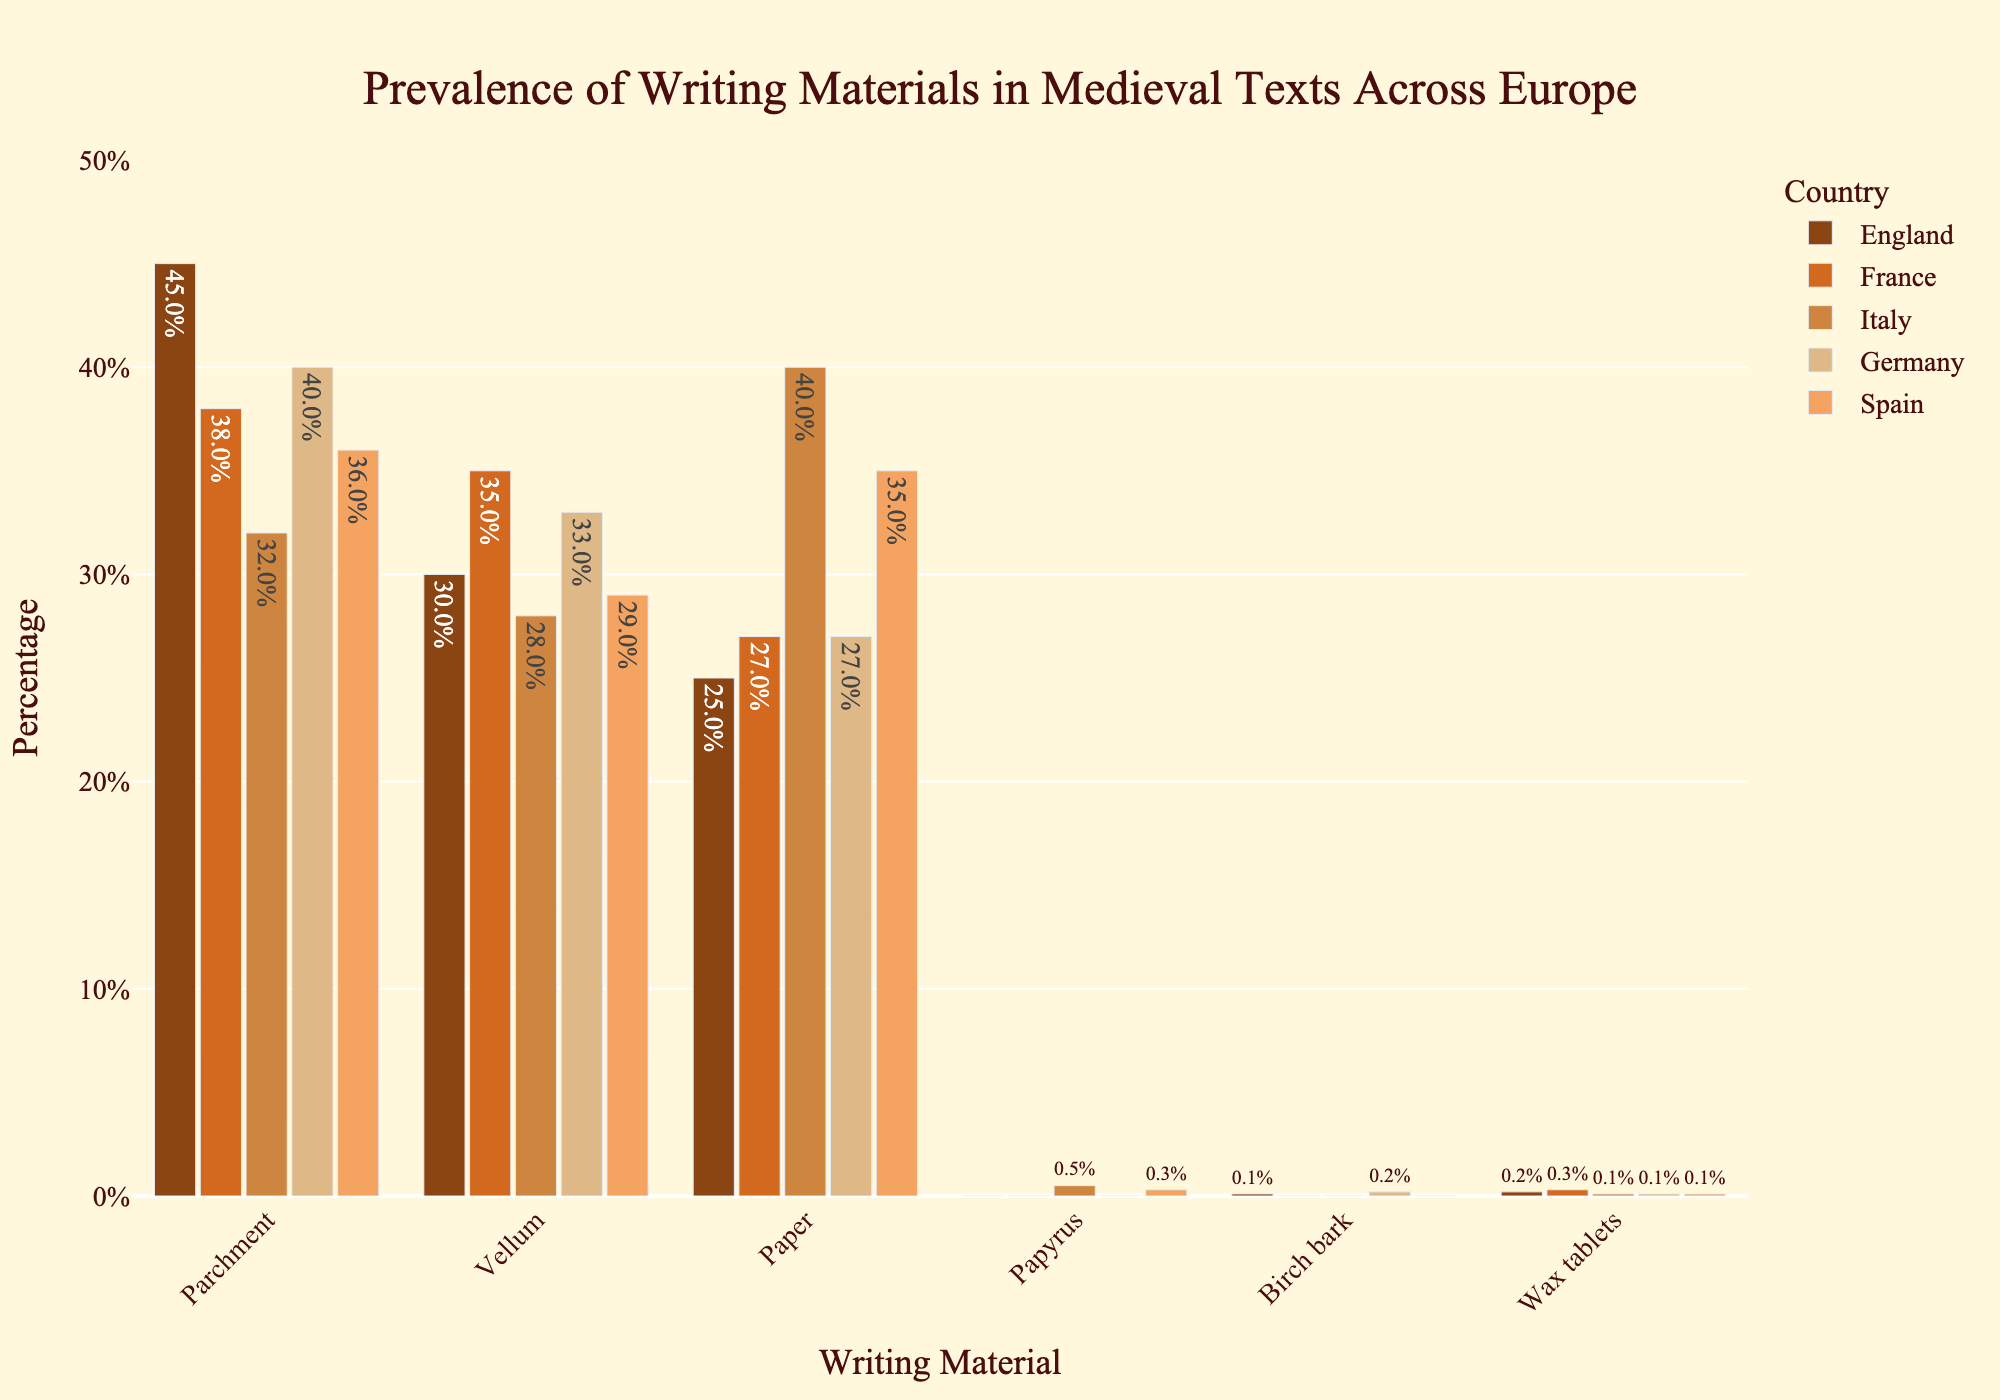What's the most prevalent writing material in England? To find the answer, look at the bar heights grouped under England for each writing material. The highest bar indicates the most prevalent material.
Answer: Parchment Which country has the highest percentage for Paper? Look at the bar heights grouped under Paper for each country. The tallest bar corresponds to the highest percentage.
Answer: Italy What is the difference in the percentage of Vellum between Germany and Spain? Check the bar heights for Vellum under Germany and Spain and calculate the difference between these two values. 33% - 29% = 4%
Answer: 4% Which writing material has the lowest overall use across all countries? Identify the smallest bars across all writing materials in the chart. The material with the smallest bar heights consistently across all countries is the least used.
Answer: Papyrus How does the prevalence of Parchment in France compare to Italy? Compare the heights of the Parchment bars between France and Italy. France has a taller bar for Parchment than Italy.
Answer: Higher Add up the percentages of Birch bark and Wax tablets in Germany. What is the result? Look at the bars representing Birch bark and Wax tablets in Germany. Add their percentages: 0.2% for Birch bark + 0.1% for Wax tablets = 0.3%
Answer: 0.3% What material is equally prevalent in France and Spain? Check the bars of all materials for both France and Spain. The material with bars of the same height in both countries is equally prevalent.
Answer: Paper Which country shows a minimal presence (below 1%) of three rare writing materials (Papyrus, Birch bark, and Wax tablets)? Find the bars representing Papyrus, Birch bark, and Wax tablets. Identify the country with all three bars lower than 1%.
Answer: England What is the total percentage of Paper across all five countries? Sum the percentages of Paper for each country: 25% (England) + 27% (France) + 40% (Italy) + 27% (Germany) + 35% (Spain) = 154%
Answer: 154% In which country is the use of Parchment closest to 40%? Identify the bars for Parchment and check which one is closest to the 40% mark.
Answer: Germany 